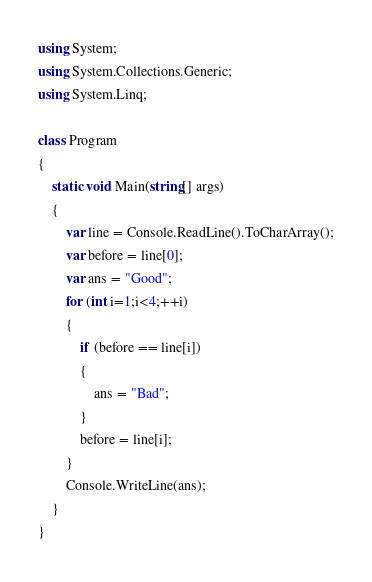Convert code to text. <code><loc_0><loc_0><loc_500><loc_500><_C#_>using System;
using System.Collections.Generic;
using System.Linq;

class Program
{
    static void Main(string[] args)
    {
        var line = Console.ReadLine().ToCharArray();
        var before = line[0];
        var ans = "Good";
        for (int i=1;i<4;++i)
        {
            if (before == line[i])
            {
                ans = "Bad";
            }
            before = line[i];
        }
        Console.WriteLine(ans);
    }
}

</code> 